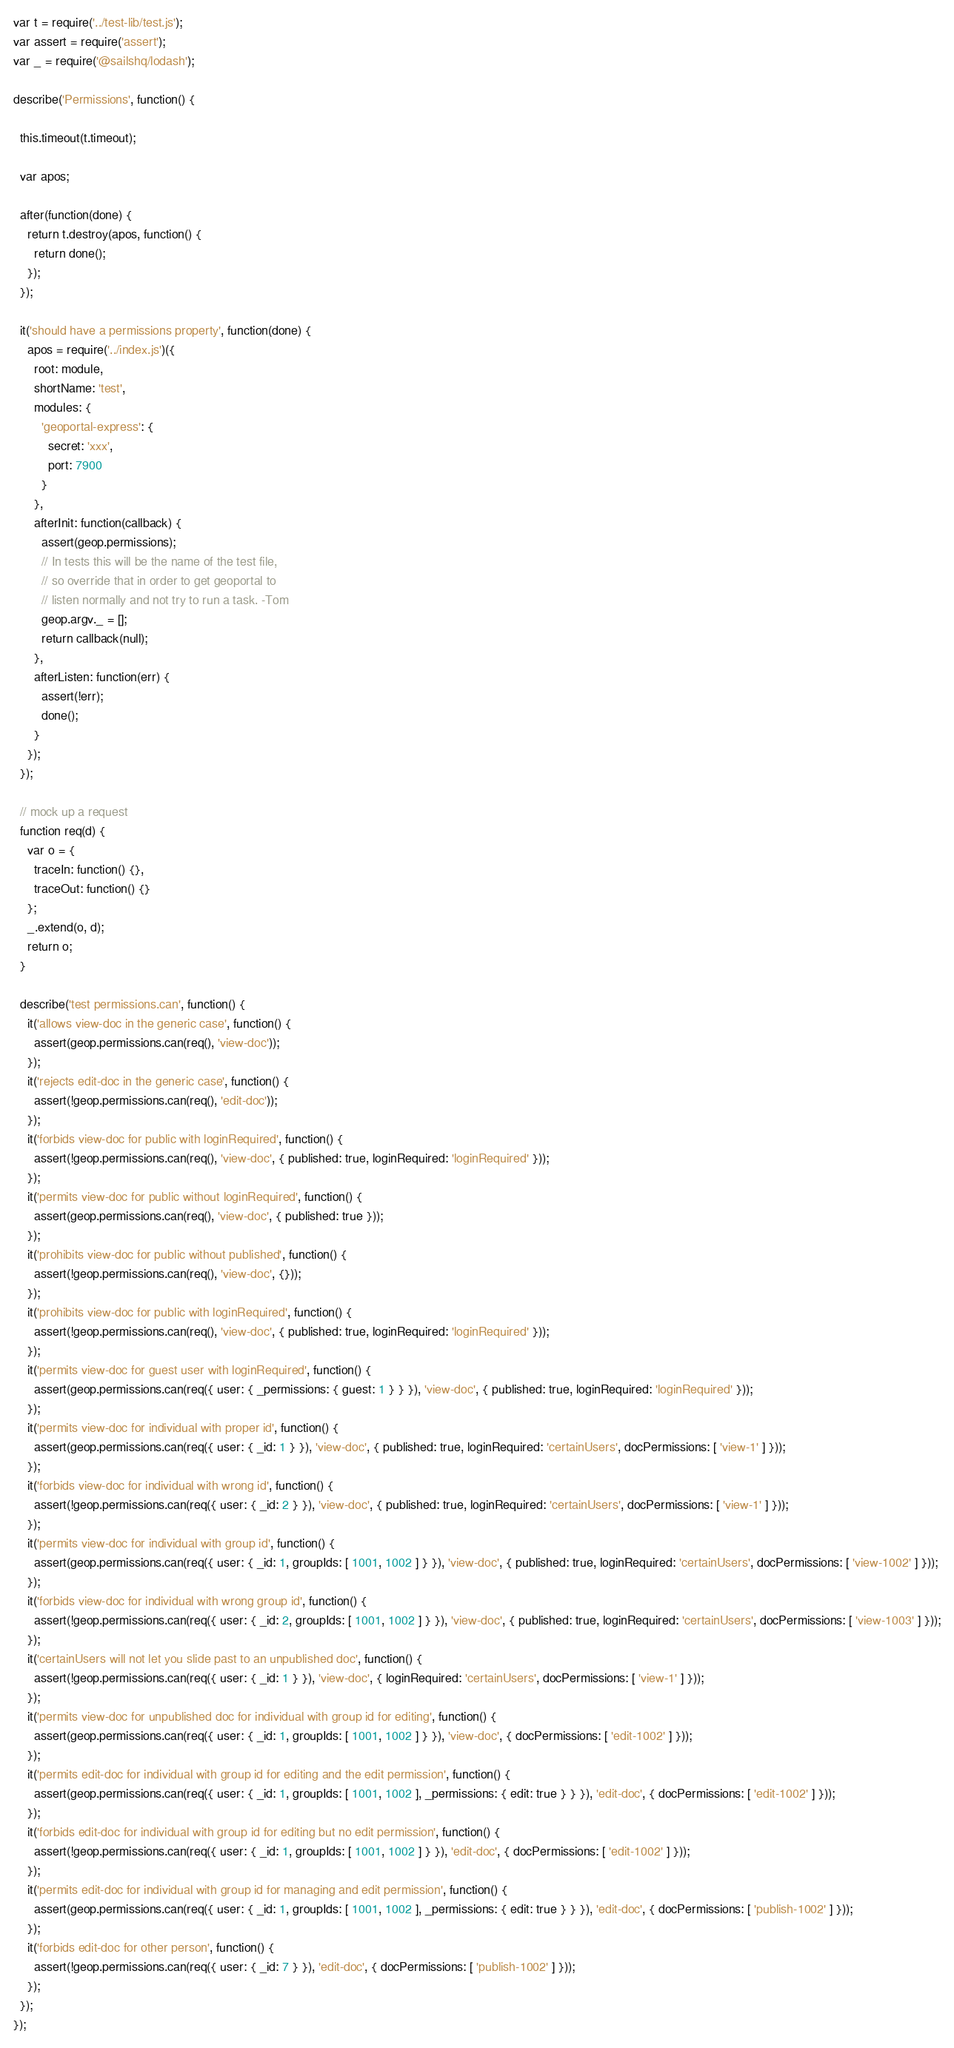Convert code to text. <code><loc_0><loc_0><loc_500><loc_500><_JavaScript_>var t = require('../test-lib/test.js');
var assert = require('assert');
var _ = require('@sailshq/lodash');

describe('Permissions', function() {

  this.timeout(t.timeout);

  var apos;

  after(function(done) {
    return t.destroy(apos, function() {
      return done();
    });
  });

  it('should have a permissions property', function(done) {
    apos = require('../index.js')({
      root: module,
      shortName: 'test',
      modules: {
        'geoportal-express': {
          secret: 'xxx',
          port: 7900
        }
      },
      afterInit: function(callback) {
        assert(geop.permissions);
        // In tests this will be the name of the test file,
        // so override that in order to get geoportal to
        // listen normally and not try to run a task. -Tom
        geop.argv._ = [];
        return callback(null);
      },
      afterListen: function(err) {
        assert(!err);
        done();
      }
    });
  });

  // mock up a request
  function req(d) {
    var o = {
      traceIn: function() {},
      traceOut: function() {}
    };
    _.extend(o, d);
    return o;
  }

  describe('test permissions.can', function() {
    it('allows view-doc in the generic case', function() {
      assert(geop.permissions.can(req(), 'view-doc'));
    });
    it('rejects edit-doc in the generic case', function() {
      assert(!geop.permissions.can(req(), 'edit-doc'));
    });
    it('forbids view-doc for public with loginRequired', function() {
      assert(!geop.permissions.can(req(), 'view-doc', { published: true, loginRequired: 'loginRequired' }));
    });
    it('permits view-doc for public without loginRequired', function() {
      assert(geop.permissions.can(req(), 'view-doc', { published: true }));
    });
    it('prohibits view-doc for public without published', function() {
      assert(!geop.permissions.can(req(), 'view-doc', {}));
    });
    it('prohibits view-doc for public with loginRequired', function() {
      assert(!geop.permissions.can(req(), 'view-doc', { published: true, loginRequired: 'loginRequired' }));
    });
    it('permits view-doc for guest user with loginRequired', function() {
      assert(geop.permissions.can(req({ user: { _permissions: { guest: 1 } } }), 'view-doc', { published: true, loginRequired: 'loginRequired' }));
    });
    it('permits view-doc for individual with proper id', function() {
      assert(geop.permissions.can(req({ user: { _id: 1 } }), 'view-doc', { published: true, loginRequired: 'certainUsers', docPermissions: [ 'view-1' ] }));
    });
    it('forbids view-doc for individual with wrong id', function() {
      assert(!geop.permissions.can(req({ user: { _id: 2 } }), 'view-doc', { published: true, loginRequired: 'certainUsers', docPermissions: [ 'view-1' ] }));
    });
    it('permits view-doc for individual with group id', function() {
      assert(geop.permissions.can(req({ user: { _id: 1, groupIds: [ 1001, 1002 ] } }), 'view-doc', { published: true, loginRequired: 'certainUsers', docPermissions: [ 'view-1002' ] }));
    });
    it('forbids view-doc for individual with wrong group id', function() {
      assert(!geop.permissions.can(req({ user: { _id: 2, groupIds: [ 1001, 1002 ] } }), 'view-doc', { published: true, loginRequired: 'certainUsers', docPermissions: [ 'view-1003' ] }));
    });
    it('certainUsers will not let you slide past to an unpublished doc', function() {
      assert(!geop.permissions.can(req({ user: { _id: 1 } }), 'view-doc', { loginRequired: 'certainUsers', docPermissions: [ 'view-1' ] }));
    });
    it('permits view-doc for unpublished doc for individual with group id for editing', function() {
      assert(geop.permissions.can(req({ user: { _id: 1, groupIds: [ 1001, 1002 ] } }), 'view-doc', { docPermissions: [ 'edit-1002' ] }));
    });
    it('permits edit-doc for individual with group id for editing and the edit permission', function() {
      assert(geop.permissions.can(req({ user: { _id: 1, groupIds: [ 1001, 1002 ], _permissions: { edit: true } } }), 'edit-doc', { docPermissions: [ 'edit-1002' ] }));
    });
    it('forbids edit-doc for individual with group id for editing but no edit permission', function() {
      assert(!geop.permissions.can(req({ user: { _id: 1, groupIds: [ 1001, 1002 ] } }), 'edit-doc', { docPermissions: [ 'edit-1002' ] }));
    });
    it('permits edit-doc for individual with group id for managing and edit permission', function() {
      assert(geop.permissions.can(req({ user: { _id: 1, groupIds: [ 1001, 1002 ], _permissions: { edit: true } } }), 'edit-doc', { docPermissions: [ 'publish-1002' ] }));
    });
    it('forbids edit-doc for other person', function() {
      assert(!geop.permissions.can(req({ user: { _id: 7 } }), 'edit-doc', { docPermissions: [ 'publish-1002' ] }));
    });
  });
});
</code> 